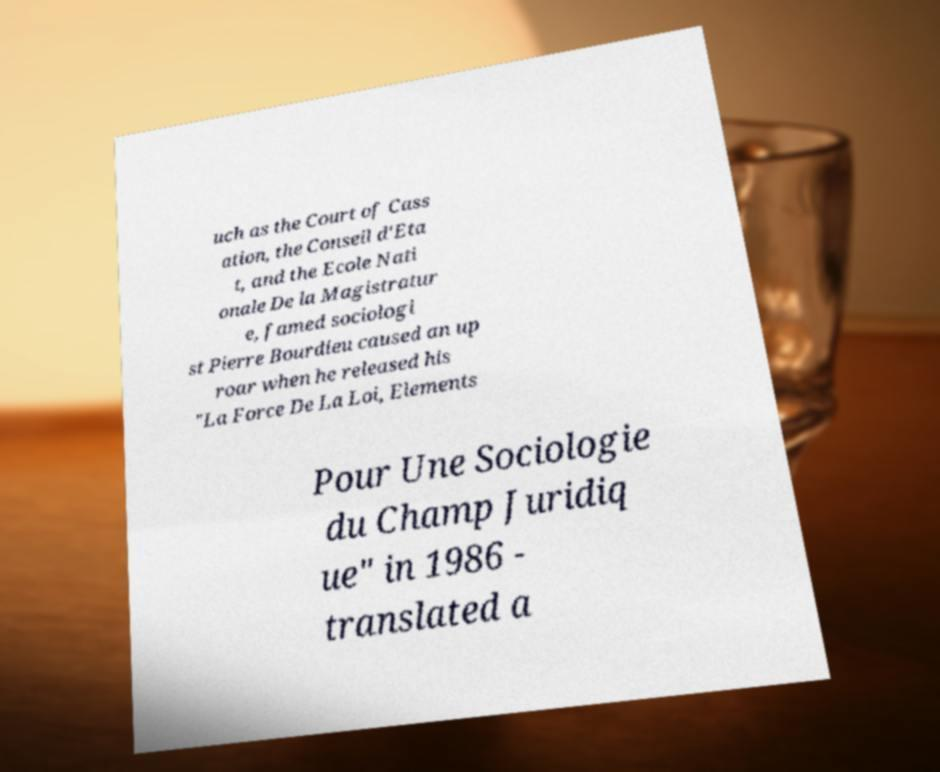I need the written content from this picture converted into text. Can you do that? uch as the Court of Cass ation, the Conseil d'Eta t, and the Ecole Nati onale De la Magistratur e, famed sociologi st Pierre Bourdieu caused an up roar when he released his "La Force De La Loi, Elements Pour Une Sociologie du Champ Juridiq ue" in 1986 - translated a 